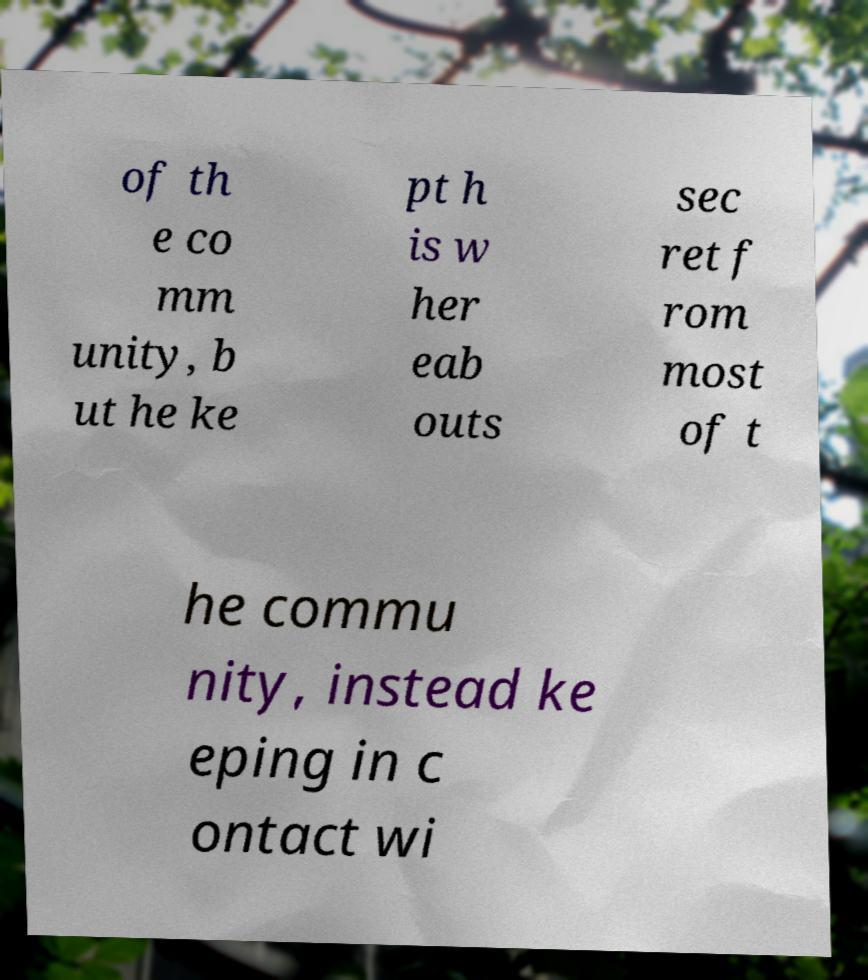Please identify and transcribe the text found in this image. of th e co mm unity, b ut he ke pt h is w her eab outs sec ret f rom most of t he commu nity, instead ke eping in c ontact wi 